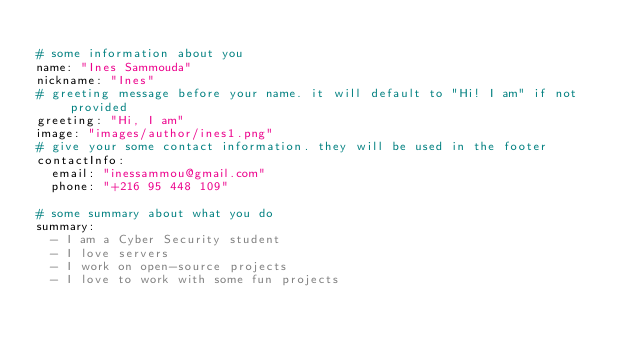Convert code to text. <code><loc_0><loc_0><loc_500><loc_500><_YAML_>
# some information about you
name: "Ines Sammouda"
nickname: "Ines"
# greeting message before your name. it will default to "Hi! I am" if not provided
greeting: "Hi, I am"
image: "images/author/ines1.png"
# give your some contact information. they will be used in the footer
contactInfo:
  email: "inessammou@gmail.com"
  phone: "+216 95 448 109"

# some summary about what you do
summary:
  - I am a Cyber Security student
  - I love servers
  - I work on open-source projects
  - I love to work with some fun projects</code> 